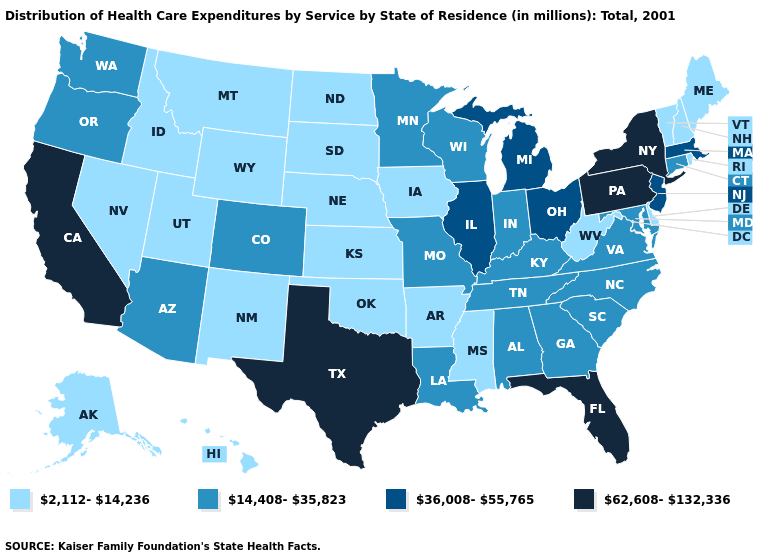Among the states that border Mississippi , which have the lowest value?
Short answer required. Arkansas. Is the legend a continuous bar?
Quick response, please. No. Which states hav the highest value in the South?
Give a very brief answer. Florida, Texas. Which states have the highest value in the USA?
Write a very short answer. California, Florida, New York, Pennsylvania, Texas. What is the lowest value in the USA?
Answer briefly. 2,112-14,236. Is the legend a continuous bar?
Concise answer only. No. Does Florida have the highest value in the USA?
Answer briefly. Yes. Name the states that have a value in the range 2,112-14,236?
Be succinct. Alaska, Arkansas, Delaware, Hawaii, Idaho, Iowa, Kansas, Maine, Mississippi, Montana, Nebraska, Nevada, New Hampshire, New Mexico, North Dakota, Oklahoma, Rhode Island, South Dakota, Utah, Vermont, West Virginia, Wyoming. Which states hav the highest value in the MidWest?
Concise answer only. Illinois, Michigan, Ohio. Which states have the highest value in the USA?
Give a very brief answer. California, Florida, New York, Pennsylvania, Texas. Does New Hampshire have a higher value than Iowa?
Concise answer only. No. How many symbols are there in the legend?
Concise answer only. 4. Name the states that have a value in the range 14,408-35,823?
Write a very short answer. Alabama, Arizona, Colorado, Connecticut, Georgia, Indiana, Kentucky, Louisiana, Maryland, Minnesota, Missouri, North Carolina, Oregon, South Carolina, Tennessee, Virginia, Washington, Wisconsin. Which states hav the highest value in the South?
Keep it brief. Florida, Texas. Among the states that border New York , which have the highest value?
Write a very short answer. Pennsylvania. 